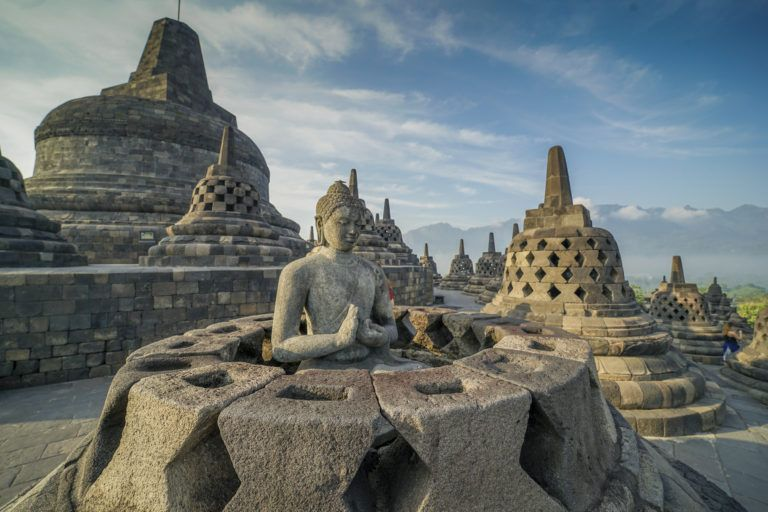Imagine visiting this temple at sunrise. How would it look? Imagine standing at the base of Borobodur Temple just before dawn. The sky is a deep indigo, gradually lightening with hints of gold as the first light of the sun begins to crest the horizon. As the sun rises, warm golden rays bathe the ancient stone structures, casting long shadows that dance across the intricate carvings. The bell-shaped stupas and statues of Buddha seem to come alive in the warm glow, their details more pronounced and vibrant. Mist from the nearby jungles drifts lazily around the temple, adding a mystical quality to the already breathtaking scene. The serene atmosphere is further deepened by the distant chirping of birds, making the temple feel like a sacred, timeless sanctuary. 